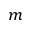Convert formula to latex. <formula><loc_0><loc_0><loc_500><loc_500>m</formula> 